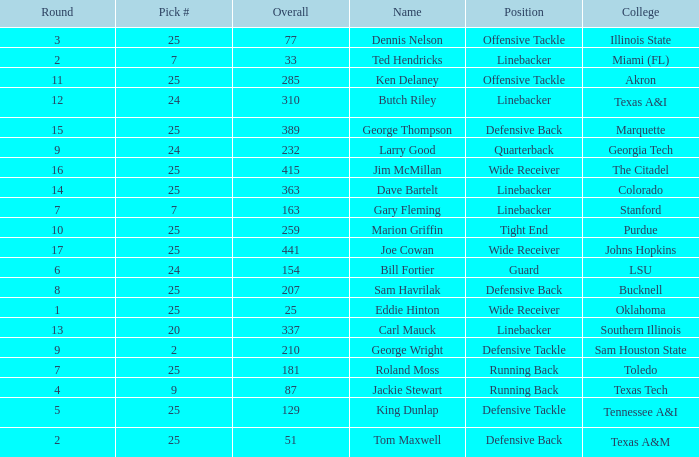Pick # of 25, and an Overall of 207 has what name? Sam Havrilak. 